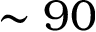<formula> <loc_0><loc_0><loc_500><loc_500>\sim 9 0</formula> 